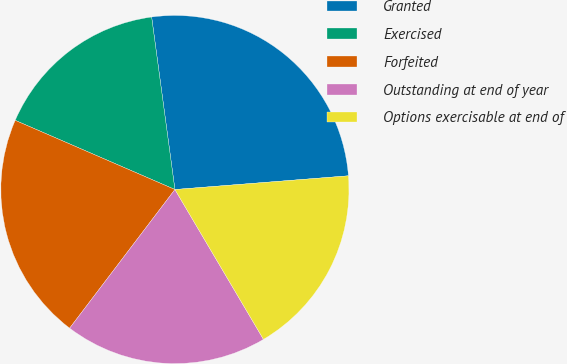<chart> <loc_0><loc_0><loc_500><loc_500><pie_chart><fcel>Granted<fcel>Exercised<fcel>Forfeited<fcel>Outstanding at end of year<fcel>Options exercisable at end of<nl><fcel>25.88%<fcel>16.36%<fcel>21.17%<fcel>18.83%<fcel>17.76%<nl></chart> 